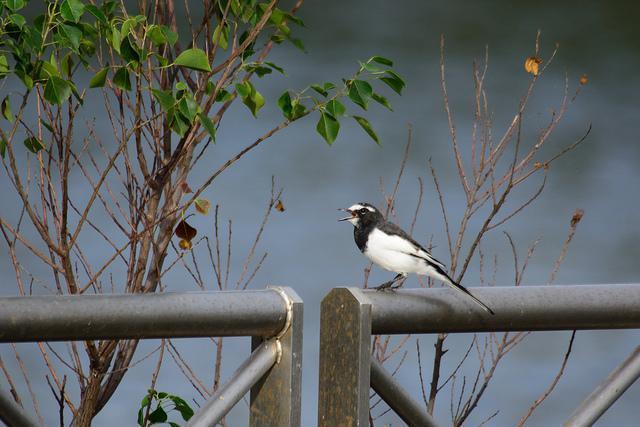How many birds are in the picture?
Give a very brief answer. 1. How many birds are there?
Give a very brief answer. 1. How many light blue umbrellas are in the image?
Give a very brief answer. 0. 